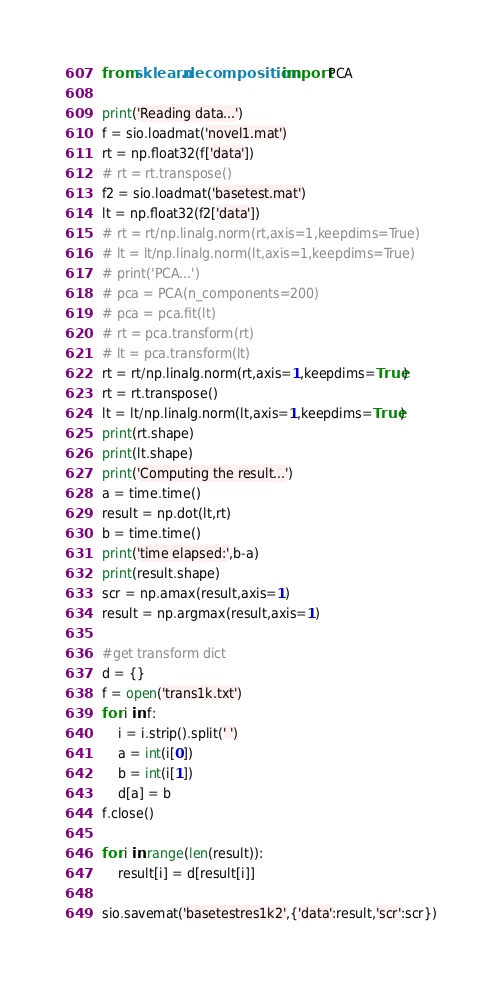Convert code to text. <code><loc_0><loc_0><loc_500><loc_500><_Python_>from sklearn.decomposition import PCA

print('Reading data...')
f = sio.loadmat('novel1.mat')
rt = np.float32(f['data'])
# rt = rt.transpose()
f2 = sio.loadmat('basetest.mat')
lt = np.float32(f2['data'])
# rt = rt/np.linalg.norm(rt,axis=1,keepdims=True)
# lt = lt/np.linalg.norm(lt,axis=1,keepdims=True)
# print('PCA...')
# pca = PCA(n_components=200)
# pca = pca.fit(lt)
# rt = pca.transform(rt)
# lt = pca.transform(lt)
rt = rt/np.linalg.norm(rt,axis=1,keepdims=True)
rt = rt.transpose()
lt = lt/np.linalg.norm(lt,axis=1,keepdims=True)
print(rt.shape)
print(lt.shape)
print('Computing the result...')
a = time.time()
result = np.dot(lt,rt)
b = time.time()
print('time elapsed:',b-a)
print(result.shape)
scr = np.amax(result,axis=1)
result = np.argmax(result,axis=1)

#get transform dict
d = {}
f = open('trans1k.txt')
for i in f:
	i = i.strip().split(' ')
	a = int(i[0])
	b = int(i[1])
	d[a] = b
f.close()

for i in range(len(result)):
	result[i] = d[result[i]]

sio.savemat('basetestres1k2',{'data':result,'scr':scr})</code> 